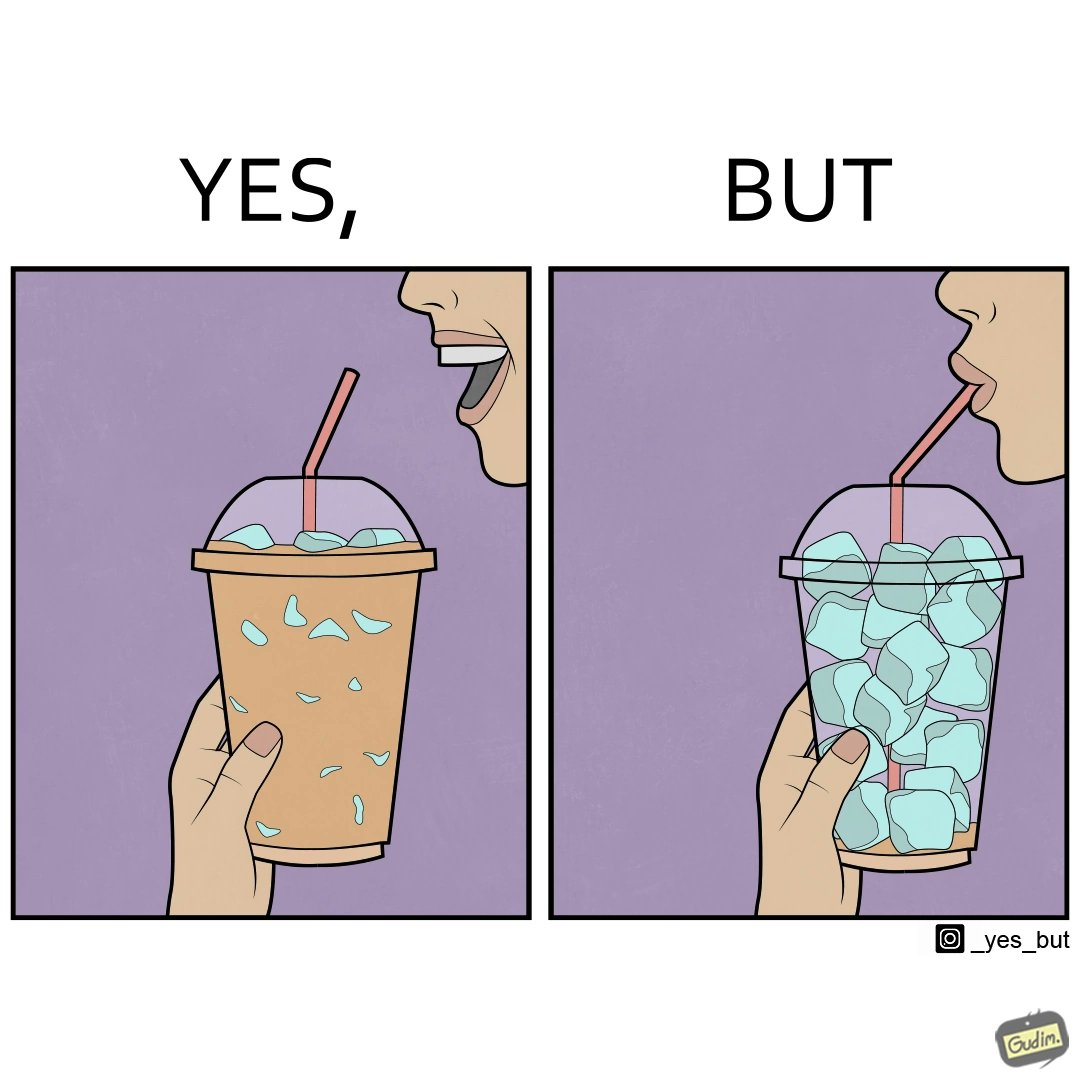Describe what you see in this image. The image is funny, as the drink seems to be full to begin with, while most of the volume of the drink is occupied by the ice cubes. 